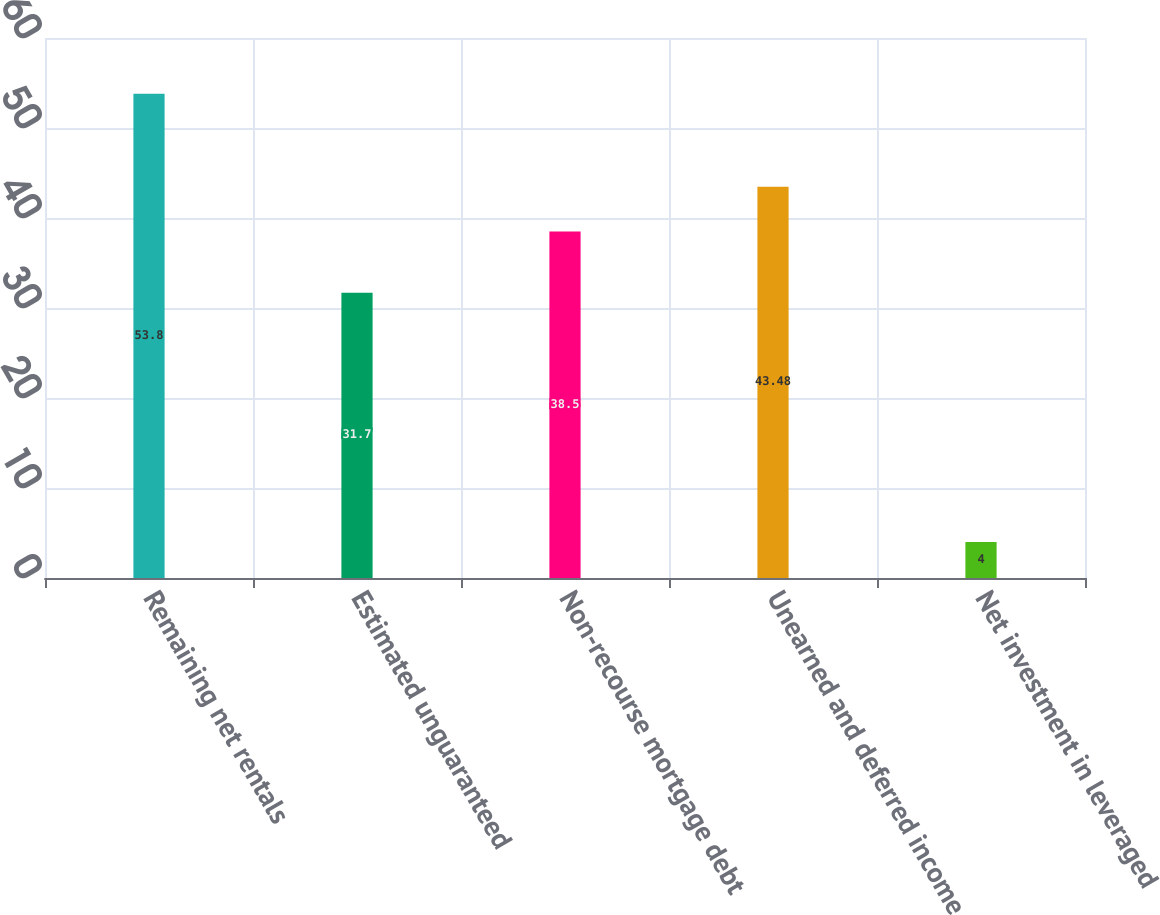<chart> <loc_0><loc_0><loc_500><loc_500><bar_chart><fcel>Remaining net rentals<fcel>Estimated unguaranteed<fcel>Non-recourse mortgage debt<fcel>Unearned and deferred income<fcel>Net investment in leveraged<nl><fcel>53.8<fcel>31.7<fcel>38.5<fcel>43.48<fcel>4<nl></chart> 